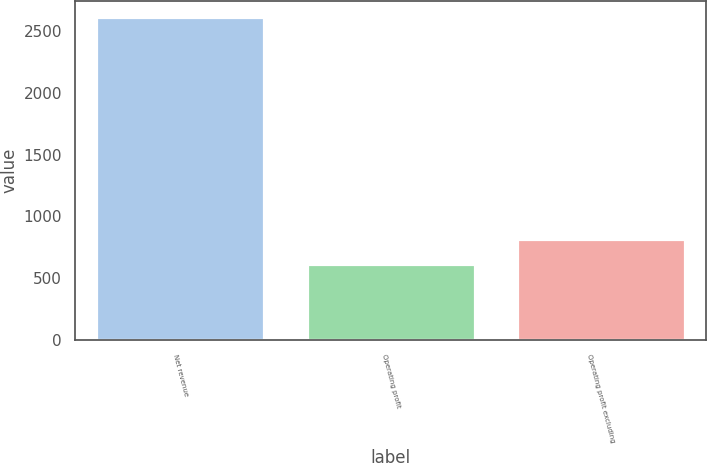Convert chart. <chart><loc_0><loc_0><loc_500><loc_500><bar_chart><fcel>Net revenue<fcel>Operating profit<fcel>Operating profit excluding<nl><fcel>2612<fcel>617<fcel>816.5<nl></chart> 